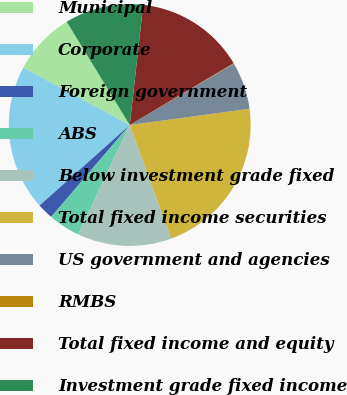Convert chart. <chart><loc_0><loc_0><loc_500><loc_500><pie_chart><fcel>Municipal<fcel>Corporate<fcel>Foreign government<fcel>ABS<fcel>Below investment grade fixed<fcel>Total fixed income securities<fcel>US government and agencies<fcel>RMBS<fcel>Total fixed income and equity<fcel>Investment grade fixed income<nl><fcel>8.41%<fcel>19.47%<fcel>2.15%<fcel>4.24%<fcel>12.59%<fcel>21.56%<fcel>6.33%<fcel>0.07%<fcel>14.68%<fcel>10.5%<nl></chart> 